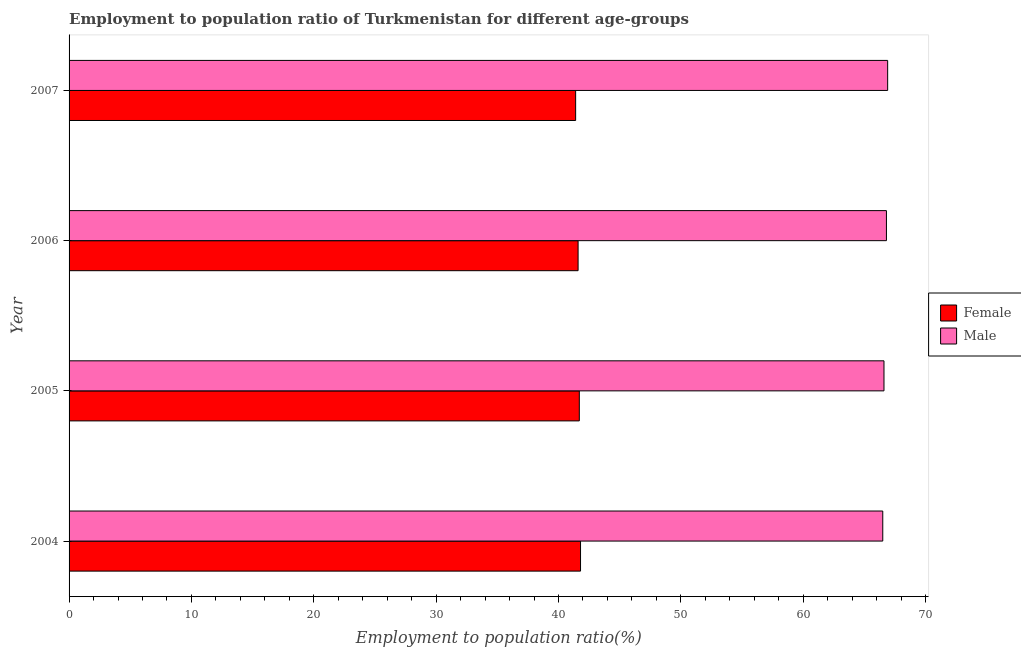How many groups of bars are there?
Give a very brief answer. 4. Are the number of bars on each tick of the Y-axis equal?
Give a very brief answer. Yes. How many bars are there on the 2nd tick from the bottom?
Offer a terse response. 2. What is the employment to population ratio(male) in 2005?
Your answer should be very brief. 66.6. Across all years, what is the maximum employment to population ratio(female)?
Provide a short and direct response. 41.8. Across all years, what is the minimum employment to population ratio(male)?
Offer a very short reply. 66.5. In which year was the employment to population ratio(male) maximum?
Your answer should be compact. 2007. What is the total employment to population ratio(female) in the graph?
Make the answer very short. 166.5. What is the difference between the employment to population ratio(male) in 2005 and that in 2006?
Offer a very short reply. -0.2. What is the difference between the employment to population ratio(female) in 2006 and the employment to population ratio(male) in 2004?
Offer a very short reply. -24.9. What is the average employment to population ratio(female) per year?
Offer a terse response. 41.62. In the year 2007, what is the difference between the employment to population ratio(male) and employment to population ratio(female)?
Your response must be concise. 25.5. In how many years, is the employment to population ratio(male) greater than 50 %?
Give a very brief answer. 4. What is the ratio of the employment to population ratio(male) in 2005 to that in 2007?
Keep it short and to the point. 1. Is the employment to population ratio(male) in 2004 less than that in 2006?
Ensure brevity in your answer.  Yes. What is the difference between the highest and the lowest employment to population ratio(male)?
Your answer should be compact. 0.4. In how many years, is the employment to population ratio(female) greater than the average employment to population ratio(female) taken over all years?
Offer a very short reply. 2. Is the sum of the employment to population ratio(female) in 2004 and 2005 greater than the maximum employment to population ratio(male) across all years?
Make the answer very short. Yes. Are all the bars in the graph horizontal?
Make the answer very short. Yes. What is the difference between two consecutive major ticks on the X-axis?
Keep it short and to the point. 10. Are the values on the major ticks of X-axis written in scientific E-notation?
Your response must be concise. No. Does the graph contain grids?
Provide a short and direct response. No. What is the title of the graph?
Your answer should be very brief. Employment to population ratio of Turkmenistan for different age-groups. Does "Working capital" appear as one of the legend labels in the graph?
Ensure brevity in your answer.  No. What is the label or title of the X-axis?
Keep it short and to the point. Employment to population ratio(%). What is the label or title of the Y-axis?
Ensure brevity in your answer.  Year. What is the Employment to population ratio(%) in Female in 2004?
Your response must be concise. 41.8. What is the Employment to population ratio(%) of Male in 2004?
Ensure brevity in your answer.  66.5. What is the Employment to population ratio(%) of Female in 2005?
Give a very brief answer. 41.7. What is the Employment to population ratio(%) in Male in 2005?
Ensure brevity in your answer.  66.6. What is the Employment to population ratio(%) of Female in 2006?
Provide a succinct answer. 41.6. What is the Employment to population ratio(%) of Male in 2006?
Give a very brief answer. 66.8. What is the Employment to population ratio(%) in Female in 2007?
Give a very brief answer. 41.4. What is the Employment to population ratio(%) in Male in 2007?
Offer a terse response. 66.9. Across all years, what is the maximum Employment to population ratio(%) in Female?
Provide a short and direct response. 41.8. Across all years, what is the maximum Employment to population ratio(%) of Male?
Your response must be concise. 66.9. Across all years, what is the minimum Employment to population ratio(%) in Female?
Provide a short and direct response. 41.4. Across all years, what is the minimum Employment to population ratio(%) of Male?
Provide a succinct answer. 66.5. What is the total Employment to population ratio(%) of Female in the graph?
Keep it short and to the point. 166.5. What is the total Employment to population ratio(%) in Male in the graph?
Provide a succinct answer. 266.8. What is the difference between the Employment to population ratio(%) of Female in 2004 and that in 2005?
Keep it short and to the point. 0.1. What is the difference between the Employment to population ratio(%) of Male in 2004 and that in 2006?
Your answer should be very brief. -0.3. What is the difference between the Employment to population ratio(%) in Male in 2005 and that in 2006?
Make the answer very short. -0.2. What is the difference between the Employment to population ratio(%) of Male in 2005 and that in 2007?
Provide a short and direct response. -0.3. What is the difference between the Employment to population ratio(%) of Male in 2006 and that in 2007?
Keep it short and to the point. -0.1. What is the difference between the Employment to population ratio(%) in Female in 2004 and the Employment to population ratio(%) in Male in 2005?
Your answer should be very brief. -24.8. What is the difference between the Employment to population ratio(%) in Female in 2004 and the Employment to population ratio(%) in Male in 2007?
Make the answer very short. -25.1. What is the difference between the Employment to population ratio(%) of Female in 2005 and the Employment to population ratio(%) of Male in 2006?
Your answer should be very brief. -25.1. What is the difference between the Employment to population ratio(%) in Female in 2005 and the Employment to population ratio(%) in Male in 2007?
Your response must be concise. -25.2. What is the difference between the Employment to population ratio(%) of Female in 2006 and the Employment to population ratio(%) of Male in 2007?
Keep it short and to the point. -25.3. What is the average Employment to population ratio(%) in Female per year?
Provide a succinct answer. 41.62. What is the average Employment to population ratio(%) in Male per year?
Your answer should be compact. 66.7. In the year 2004, what is the difference between the Employment to population ratio(%) in Female and Employment to population ratio(%) in Male?
Ensure brevity in your answer.  -24.7. In the year 2005, what is the difference between the Employment to population ratio(%) of Female and Employment to population ratio(%) of Male?
Keep it short and to the point. -24.9. In the year 2006, what is the difference between the Employment to population ratio(%) of Female and Employment to population ratio(%) of Male?
Offer a terse response. -25.2. In the year 2007, what is the difference between the Employment to population ratio(%) in Female and Employment to population ratio(%) in Male?
Give a very brief answer. -25.5. What is the ratio of the Employment to population ratio(%) in Male in 2004 to that in 2005?
Your answer should be very brief. 1. What is the ratio of the Employment to population ratio(%) in Female in 2004 to that in 2007?
Provide a succinct answer. 1.01. What is the ratio of the Employment to population ratio(%) in Male in 2004 to that in 2007?
Your answer should be compact. 0.99. What is the ratio of the Employment to population ratio(%) in Female in 2005 to that in 2006?
Provide a short and direct response. 1. What is the ratio of the Employment to population ratio(%) in Male in 2005 to that in 2006?
Ensure brevity in your answer.  1. What is the ratio of the Employment to population ratio(%) of Female in 2005 to that in 2007?
Provide a succinct answer. 1.01. What is the ratio of the Employment to population ratio(%) of Male in 2005 to that in 2007?
Your response must be concise. 1. What is the ratio of the Employment to population ratio(%) of Male in 2006 to that in 2007?
Keep it short and to the point. 1. What is the difference between the highest and the second highest Employment to population ratio(%) in Female?
Provide a short and direct response. 0.1. What is the difference between the highest and the lowest Employment to population ratio(%) of Male?
Ensure brevity in your answer.  0.4. 